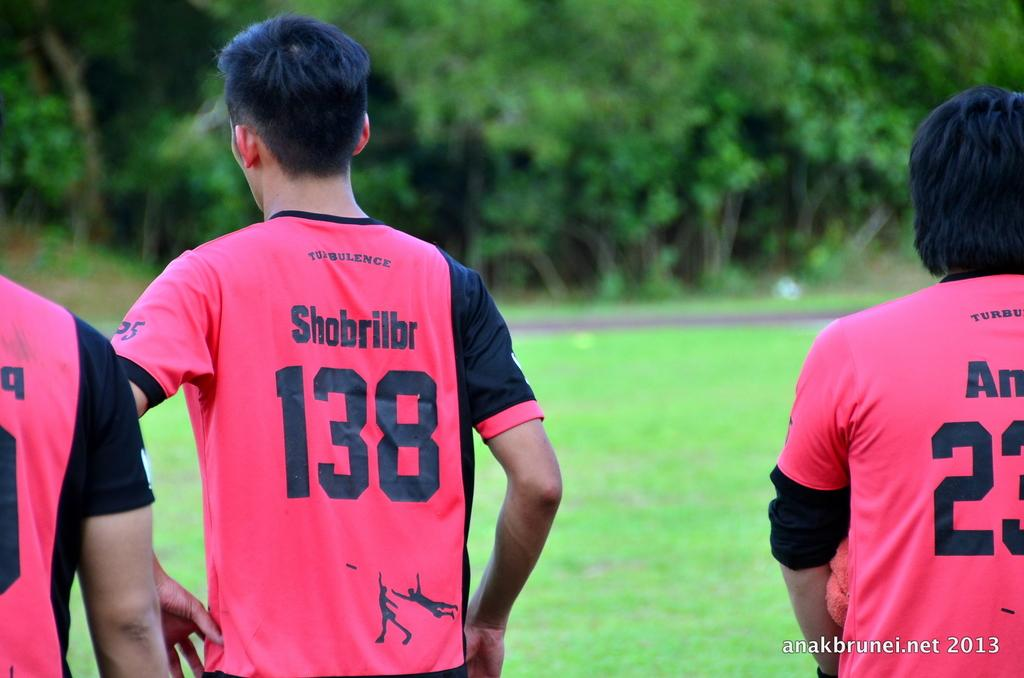<image>
Write a terse but informative summary of the picture. Player number 138 wears a red and black jersey 